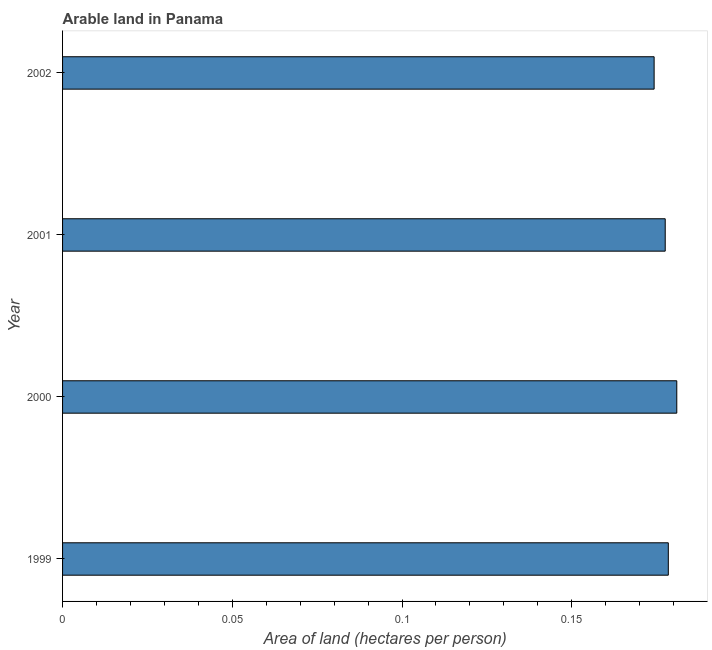Does the graph contain any zero values?
Provide a succinct answer. No. Does the graph contain grids?
Your response must be concise. No. What is the title of the graph?
Give a very brief answer. Arable land in Panama. What is the label or title of the X-axis?
Your answer should be compact. Area of land (hectares per person). What is the label or title of the Y-axis?
Your answer should be very brief. Year. What is the area of arable land in 2002?
Offer a very short reply. 0.17. Across all years, what is the maximum area of arable land?
Give a very brief answer. 0.18. Across all years, what is the minimum area of arable land?
Your answer should be very brief. 0.17. In which year was the area of arable land minimum?
Make the answer very short. 2002. What is the sum of the area of arable land?
Ensure brevity in your answer.  0.71. What is the difference between the area of arable land in 2001 and 2002?
Offer a very short reply. 0. What is the average area of arable land per year?
Provide a succinct answer. 0.18. What is the median area of arable land?
Provide a short and direct response. 0.18. What is the ratio of the area of arable land in 1999 to that in 2000?
Your response must be concise. 0.99. What is the difference between the highest and the second highest area of arable land?
Provide a succinct answer. 0. What is the difference between the highest and the lowest area of arable land?
Your answer should be very brief. 0.01. What is the difference between two consecutive major ticks on the X-axis?
Offer a terse response. 0.05. What is the Area of land (hectares per person) in 1999?
Ensure brevity in your answer.  0.18. What is the Area of land (hectares per person) of 2000?
Give a very brief answer. 0.18. What is the Area of land (hectares per person) of 2001?
Offer a terse response. 0.18. What is the Area of land (hectares per person) in 2002?
Give a very brief answer. 0.17. What is the difference between the Area of land (hectares per person) in 1999 and 2000?
Keep it short and to the point. -0. What is the difference between the Area of land (hectares per person) in 1999 and 2001?
Make the answer very short. 0. What is the difference between the Area of land (hectares per person) in 1999 and 2002?
Make the answer very short. 0. What is the difference between the Area of land (hectares per person) in 2000 and 2001?
Your answer should be compact. 0. What is the difference between the Area of land (hectares per person) in 2000 and 2002?
Make the answer very short. 0.01. What is the difference between the Area of land (hectares per person) in 2001 and 2002?
Your answer should be very brief. 0. What is the ratio of the Area of land (hectares per person) in 1999 to that in 2000?
Your answer should be compact. 0.99. What is the ratio of the Area of land (hectares per person) in 1999 to that in 2001?
Ensure brevity in your answer.  1. What is the ratio of the Area of land (hectares per person) in 1999 to that in 2002?
Your response must be concise. 1.02. What is the ratio of the Area of land (hectares per person) in 2000 to that in 2002?
Make the answer very short. 1.04. What is the ratio of the Area of land (hectares per person) in 2001 to that in 2002?
Offer a terse response. 1.02. 